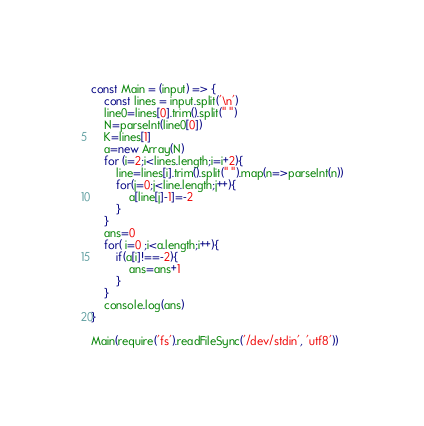<code> <loc_0><loc_0><loc_500><loc_500><_JavaScript_>const Main = (input) => {
    const lines = input.split('\n')
    line0=lines[0].trim().split(" ")
    N=parseInt(line0[0])
    K=lines[1]
    a=new Array(N)
    for (i=2;i<lines.length;i=i+2){
        line=lines[i].trim().split(" ").map(n=>parseInt(n))
        for(j=0;j<line.length;j++){
            a[line[j]-1]=-2
        }
    }
    ans=0
    for( i=0 ;i<a.length;i++){
        if(a[i]!==-2){
            ans=ans+1
        }
    }
    console.log(ans)
}

Main(require('fs').readFileSync('/dev/stdin', 'utf8'))</code> 